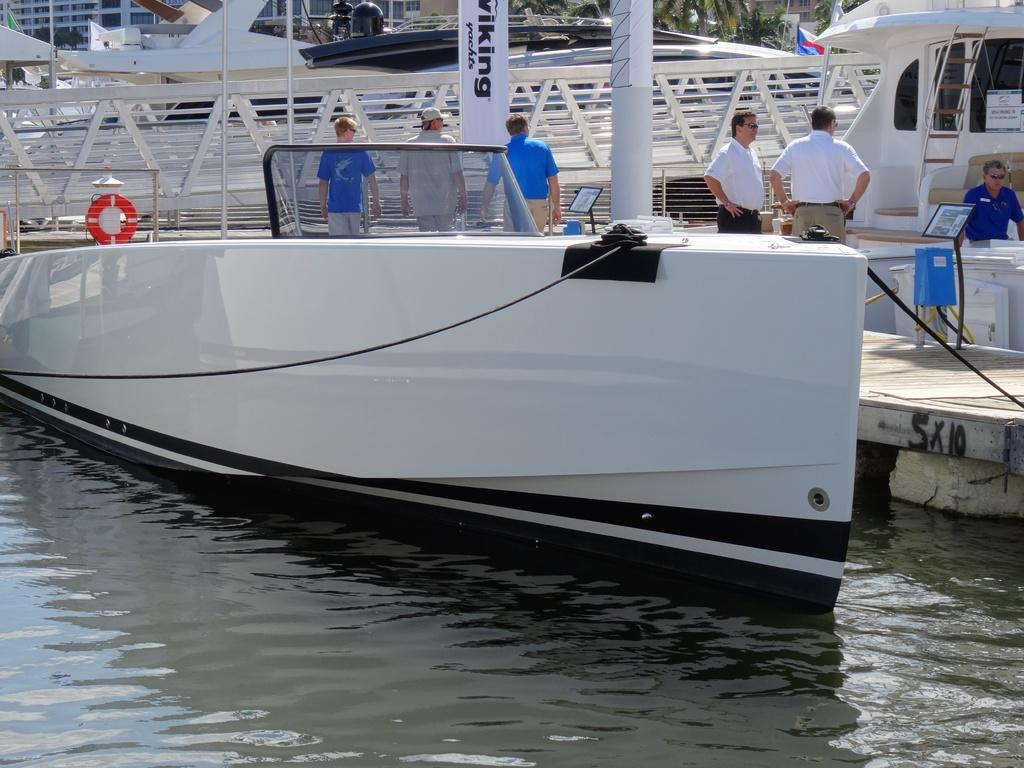What is the main subject of the image? The main subject of the image is a boat. Where is the boat located? The boat is on the water. What else can be seen in the image besides the boat? There are poles, people, boards, a flag, and various objects in the image. What can be seen in the background of the image? There are buildings and trees in the background of the image. What type of school can be seen in the image? There is no school present in the image; it features a boat on the water with various other objects and a background of buildings and trees. 